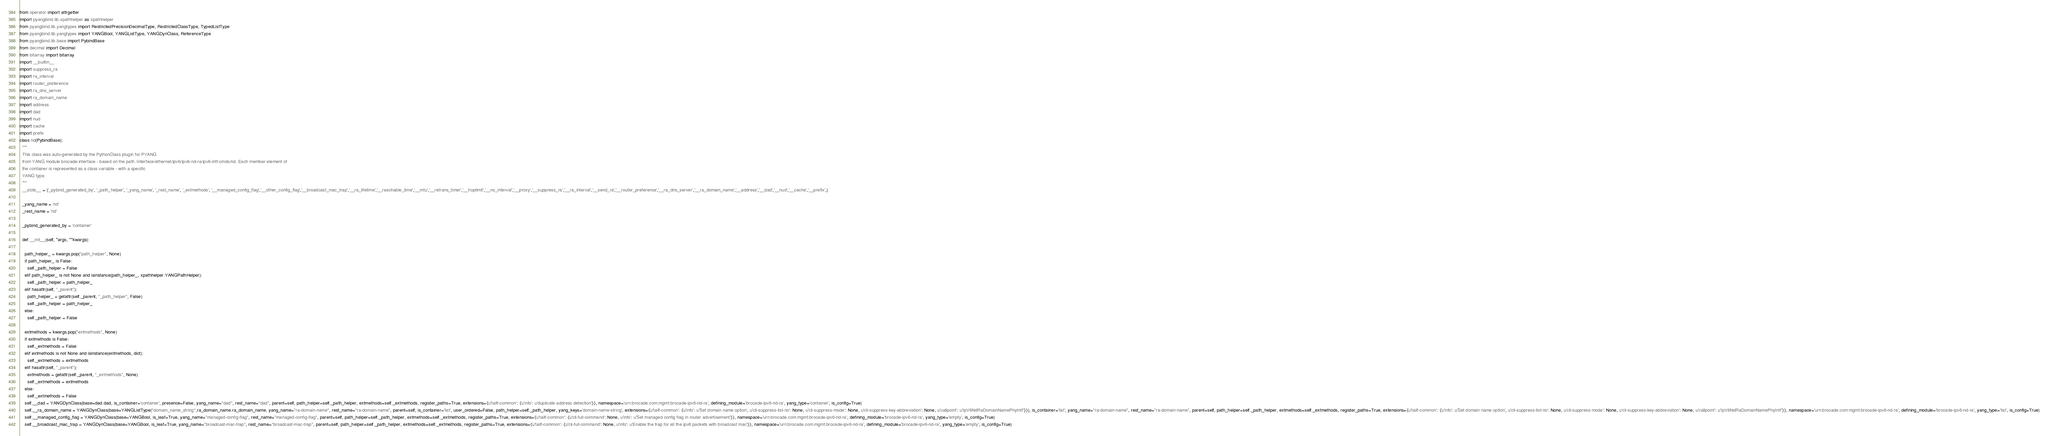<code> <loc_0><loc_0><loc_500><loc_500><_Python_>
from operator import attrgetter
import pyangbind.lib.xpathhelper as xpathhelper
from pyangbind.lib.yangtypes import RestrictedPrecisionDecimalType, RestrictedClassType, TypedListType
from pyangbind.lib.yangtypes import YANGBool, YANGListType, YANGDynClass, ReferenceType
from pyangbind.lib.base import PybindBase
from decimal import Decimal
from bitarray import bitarray
import __builtin__
import suppress_ra
import ra_interval
import router_preference
import ra_dns_server
import ra_domain_name
import address
import dad
import nud
import cache
import prefix
class nd(PybindBase):
  """
  This class was auto-generated by the PythonClass plugin for PYANG
  from YANG module brocade-interface - based on the path /interface/ethernet/ipv6/ipv6-nd-ra/ipv6-intf-cmds/nd. Each member element of
  the container is represented as a class variable - with a specific
  YANG type.
  """
  __slots__ = ('_pybind_generated_by', '_path_helper', '_yang_name', '_rest_name', '_extmethods', '__managed_config_flag','__other_config_flag','__broadcast_mac_trap','__ra_lifetime','__reachable_time','__mtu','__retrans_timer','__hoplimit','__ns_interval','__proxy','__suppress_ra','__ra_interval','__send_ra','__router_preference','__ra_dns_server','__ra_domain_name','__address','__dad','__nud','__cache','__prefix',)

  _yang_name = 'nd'
  _rest_name = 'nd'

  _pybind_generated_by = 'container'

  def __init__(self, *args, **kwargs):

    path_helper_ = kwargs.pop("path_helper", None)
    if path_helper_ is False:
      self._path_helper = False
    elif path_helper_ is not None and isinstance(path_helper_, xpathhelper.YANGPathHelper):
      self._path_helper = path_helper_
    elif hasattr(self, "_parent"):
      path_helper_ = getattr(self._parent, "_path_helper", False)
      self._path_helper = path_helper_
    else:
      self._path_helper = False

    extmethods = kwargs.pop("extmethods", None)
    if extmethods is False:
      self._extmethods = False
    elif extmethods is not None and isinstance(extmethods, dict):
      self._extmethods = extmethods
    elif hasattr(self, "_parent"):
      extmethods = getattr(self._parent, "_extmethods", None)
      self._extmethods = extmethods
    else:
      self._extmethods = False
    self.__dad = YANGDynClass(base=dad.dad, is_container='container', presence=False, yang_name="dad", rest_name="dad", parent=self, path_helper=self._path_helper, extmethods=self._extmethods, register_paths=True, extensions={u'tailf-common': {u'info': u'duplicate address detection'}}, namespace='urn:brocade.com:mgmt:brocade-ipv6-nd-ra', defining_module='brocade-ipv6-nd-ra', yang_type='container', is_config=True)
    self.__ra_domain_name = YANGDynClass(base=YANGListType("domain_name_string",ra_domain_name.ra_domain_name, yang_name="ra-domain-name", rest_name="ra-domain-name", parent=self, is_container='list', user_ordered=False, path_helper=self._path_helper, yang_keys='domain-name-string', extensions={u'tailf-common': {u'info': u'Set domain name option', u'cli-suppress-list-no': None, u'cli-suppress-mode': None, u'cli-suppress-key-abbreviation': None, u'callpoint': u'IpV6NdRaDomainNamePhyIntf'}}), is_container='list', yang_name="ra-domain-name", rest_name="ra-domain-name", parent=self, path_helper=self._path_helper, extmethods=self._extmethods, register_paths=True, extensions={u'tailf-common': {u'info': u'Set domain name option', u'cli-suppress-list-no': None, u'cli-suppress-mode': None, u'cli-suppress-key-abbreviation': None, u'callpoint': u'IpV6NdRaDomainNamePhyIntf'}}, namespace='urn:brocade.com:mgmt:brocade-ipv6-nd-ra', defining_module='brocade-ipv6-nd-ra', yang_type='list', is_config=True)
    self.__managed_config_flag = YANGDynClass(base=YANGBool, is_leaf=True, yang_name="managed-config-flag", rest_name="managed-config-flag", parent=self, path_helper=self._path_helper, extmethods=self._extmethods, register_paths=True, extensions={u'tailf-common': {u'cli-full-command': None, u'info': u'Set managed config flag in router advertisement'}}, namespace='urn:brocade.com:mgmt:brocade-ipv6-nd-ra', defining_module='brocade-ipv6-nd-ra', yang_type='empty', is_config=True)
    self.__broadcast_mac_trap = YANGDynClass(base=YANGBool, is_leaf=True, yang_name="broadcast-mac-trap", rest_name="broadcast-mac-trap", parent=self, path_helper=self._path_helper, extmethods=self._extmethods, register_paths=True, extensions={u'tailf-common': {u'cli-full-command': None, u'info': u'Enable the trap for all the ipv6 packets with broadcast mac'}}, namespace='urn:brocade.com:mgmt:brocade-ipv6-nd-ra', defining_module='brocade-ipv6-nd-ra', yang_type='empty', is_config=True)</code> 